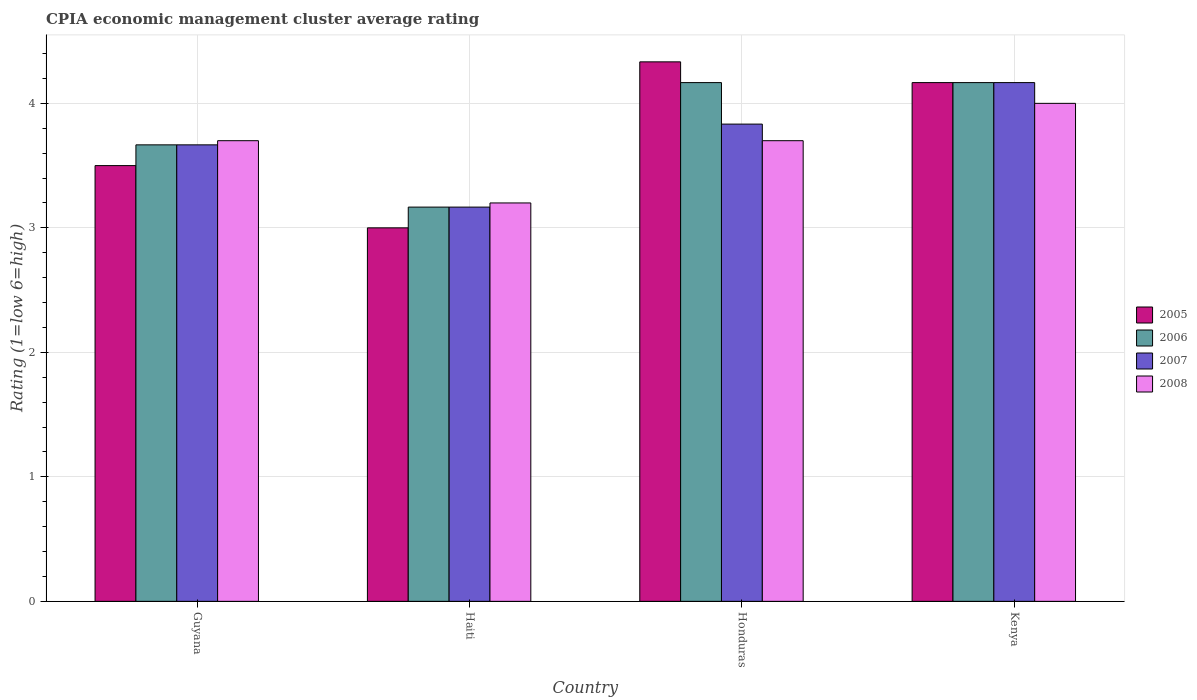Are the number of bars on each tick of the X-axis equal?
Ensure brevity in your answer.  Yes. How many bars are there on the 4th tick from the right?
Your answer should be compact. 4. What is the label of the 2nd group of bars from the left?
Offer a terse response. Haiti. What is the CPIA rating in 2006 in Kenya?
Ensure brevity in your answer.  4.17. Across all countries, what is the maximum CPIA rating in 2006?
Keep it short and to the point. 4.17. Across all countries, what is the minimum CPIA rating in 2005?
Offer a very short reply. 3. In which country was the CPIA rating in 2008 maximum?
Your answer should be compact. Kenya. In which country was the CPIA rating in 2006 minimum?
Give a very brief answer. Haiti. What is the total CPIA rating in 2005 in the graph?
Make the answer very short. 15. What is the difference between the CPIA rating in 2008 in Haiti and that in Honduras?
Offer a terse response. -0.5. What is the difference between the CPIA rating in 2008 in Honduras and the CPIA rating in 2007 in Haiti?
Your answer should be compact. 0.53. What is the average CPIA rating in 2006 per country?
Your answer should be compact. 3.79. What is the difference between the CPIA rating of/in 2007 and CPIA rating of/in 2006 in Kenya?
Offer a terse response. 0. In how many countries, is the CPIA rating in 2006 greater than 3.6?
Offer a terse response. 3. What is the ratio of the CPIA rating in 2006 in Honduras to that in Kenya?
Your answer should be compact. 1. Is the difference between the CPIA rating in 2007 in Guyana and Kenya greater than the difference between the CPIA rating in 2006 in Guyana and Kenya?
Ensure brevity in your answer.  No. What is the difference between the highest and the second highest CPIA rating in 2007?
Make the answer very short. -0.17. What is the difference between the highest and the lowest CPIA rating in 2007?
Offer a very short reply. 1. In how many countries, is the CPIA rating in 2007 greater than the average CPIA rating in 2007 taken over all countries?
Provide a succinct answer. 2. What does the 3rd bar from the left in Guyana represents?
Your response must be concise. 2007. What does the 2nd bar from the right in Honduras represents?
Your answer should be compact. 2007. How many bars are there?
Offer a very short reply. 16. Are all the bars in the graph horizontal?
Make the answer very short. No. How many countries are there in the graph?
Make the answer very short. 4. What is the difference between two consecutive major ticks on the Y-axis?
Your answer should be very brief. 1. Are the values on the major ticks of Y-axis written in scientific E-notation?
Provide a short and direct response. No. Does the graph contain any zero values?
Provide a short and direct response. No. How many legend labels are there?
Your answer should be compact. 4. How are the legend labels stacked?
Give a very brief answer. Vertical. What is the title of the graph?
Make the answer very short. CPIA economic management cluster average rating. Does "1974" appear as one of the legend labels in the graph?
Ensure brevity in your answer.  No. What is the label or title of the X-axis?
Your response must be concise. Country. What is the Rating (1=low 6=high) of 2005 in Guyana?
Your response must be concise. 3.5. What is the Rating (1=low 6=high) of 2006 in Guyana?
Your answer should be compact. 3.67. What is the Rating (1=low 6=high) of 2007 in Guyana?
Offer a very short reply. 3.67. What is the Rating (1=low 6=high) of 2008 in Guyana?
Your answer should be compact. 3.7. What is the Rating (1=low 6=high) in 2006 in Haiti?
Keep it short and to the point. 3.17. What is the Rating (1=low 6=high) of 2007 in Haiti?
Offer a terse response. 3.17. What is the Rating (1=low 6=high) in 2005 in Honduras?
Your answer should be very brief. 4.33. What is the Rating (1=low 6=high) of 2006 in Honduras?
Your answer should be compact. 4.17. What is the Rating (1=low 6=high) of 2007 in Honduras?
Give a very brief answer. 3.83. What is the Rating (1=low 6=high) in 2005 in Kenya?
Your answer should be very brief. 4.17. What is the Rating (1=low 6=high) in 2006 in Kenya?
Keep it short and to the point. 4.17. What is the Rating (1=low 6=high) of 2007 in Kenya?
Make the answer very short. 4.17. What is the Rating (1=low 6=high) of 2008 in Kenya?
Offer a very short reply. 4. Across all countries, what is the maximum Rating (1=low 6=high) of 2005?
Provide a succinct answer. 4.33. Across all countries, what is the maximum Rating (1=low 6=high) in 2006?
Offer a terse response. 4.17. Across all countries, what is the maximum Rating (1=low 6=high) of 2007?
Your answer should be compact. 4.17. Across all countries, what is the minimum Rating (1=low 6=high) in 2005?
Provide a succinct answer. 3. Across all countries, what is the minimum Rating (1=low 6=high) in 2006?
Make the answer very short. 3.17. Across all countries, what is the minimum Rating (1=low 6=high) in 2007?
Ensure brevity in your answer.  3.17. What is the total Rating (1=low 6=high) of 2005 in the graph?
Provide a succinct answer. 15. What is the total Rating (1=low 6=high) in 2006 in the graph?
Your response must be concise. 15.17. What is the total Rating (1=low 6=high) in 2007 in the graph?
Your answer should be very brief. 14.83. What is the difference between the Rating (1=low 6=high) of 2005 in Guyana and that in Haiti?
Provide a short and direct response. 0.5. What is the difference between the Rating (1=low 6=high) of 2007 in Guyana and that in Haiti?
Make the answer very short. 0.5. What is the difference between the Rating (1=low 6=high) of 2008 in Guyana and that in Haiti?
Provide a succinct answer. 0.5. What is the difference between the Rating (1=low 6=high) in 2006 in Guyana and that in Honduras?
Make the answer very short. -0.5. What is the difference between the Rating (1=low 6=high) in 2007 in Guyana and that in Honduras?
Your response must be concise. -0.17. What is the difference between the Rating (1=low 6=high) of 2008 in Guyana and that in Honduras?
Make the answer very short. 0. What is the difference between the Rating (1=low 6=high) of 2005 in Haiti and that in Honduras?
Provide a succinct answer. -1.33. What is the difference between the Rating (1=low 6=high) of 2007 in Haiti and that in Honduras?
Give a very brief answer. -0.67. What is the difference between the Rating (1=low 6=high) in 2005 in Haiti and that in Kenya?
Offer a terse response. -1.17. What is the difference between the Rating (1=low 6=high) of 2006 in Haiti and that in Kenya?
Offer a very short reply. -1. What is the difference between the Rating (1=low 6=high) of 2007 in Haiti and that in Kenya?
Your answer should be very brief. -1. What is the difference between the Rating (1=low 6=high) in 2008 in Haiti and that in Kenya?
Ensure brevity in your answer.  -0.8. What is the difference between the Rating (1=low 6=high) of 2005 in Honduras and that in Kenya?
Your answer should be very brief. 0.17. What is the difference between the Rating (1=low 6=high) of 2008 in Honduras and that in Kenya?
Provide a short and direct response. -0.3. What is the difference between the Rating (1=low 6=high) in 2006 in Guyana and the Rating (1=low 6=high) in 2007 in Haiti?
Ensure brevity in your answer.  0.5. What is the difference between the Rating (1=low 6=high) in 2006 in Guyana and the Rating (1=low 6=high) in 2008 in Haiti?
Offer a very short reply. 0.47. What is the difference between the Rating (1=low 6=high) of 2007 in Guyana and the Rating (1=low 6=high) of 2008 in Haiti?
Keep it short and to the point. 0.47. What is the difference between the Rating (1=low 6=high) in 2005 in Guyana and the Rating (1=low 6=high) in 2006 in Honduras?
Your answer should be compact. -0.67. What is the difference between the Rating (1=low 6=high) in 2006 in Guyana and the Rating (1=low 6=high) in 2007 in Honduras?
Offer a very short reply. -0.17. What is the difference between the Rating (1=low 6=high) in 2006 in Guyana and the Rating (1=low 6=high) in 2008 in Honduras?
Offer a very short reply. -0.03. What is the difference between the Rating (1=low 6=high) of 2007 in Guyana and the Rating (1=low 6=high) of 2008 in Honduras?
Offer a terse response. -0.03. What is the difference between the Rating (1=low 6=high) in 2005 in Guyana and the Rating (1=low 6=high) in 2006 in Kenya?
Provide a succinct answer. -0.67. What is the difference between the Rating (1=low 6=high) in 2007 in Guyana and the Rating (1=low 6=high) in 2008 in Kenya?
Your response must be concise. -0.33. What is the difference between the Rating (1=low 6=high) in 2005 in Haiti and the Rating (1=low 6=high) in 2006 in Honduras?
Give a very brief answer. -1.17. What is the difference between the Rating (1=low 6=high) of 2006 in Haiti and the Rating (1=low 6=high) of 2007 in Honduras?
Your answer should be compact. -0.67. What is the difference between the Rating (1=low 6=high) in 2006 in Haiti and the Rating (1=low 6=high) in 2008 in Honduras?
Ensure brevity in your answer.  -0.53. What is the difference between the Rating (1=low 6=high) of 2007 in Haiti and the Rating (1=low 6=high) of 2008 in Honduras?
Your answer should be compact. -0.53. What is the difference between the Rating (1=low 6=high) of 2005 in Haiti and the Rating (1=low 6=high) of 2006 in Kenya?
Provide a short and direct response. -1.17. What is the difference between the Rating (1=low 6=high) of 2005 in Haiti and the Rating (1=low 6=high) of 2007 in Kenya?
Offer a terse response. -1.17. What is the difference between the Rating (1=low 6=high) in 2005 in Haiti and the Rating (1=low 6=high) in 2008 in Kenya?
Give a very brief answer. -1. What is the difference between the Rating (1=low 6=high) in 2006 in Haiti and the Rating (1=low 6=high) in 2007 in Kenya?
Your answer should be compact. -1. What is the difference between the Rating (1=low 6=high) of 2006 in Haiti and the Rating (1=low 6=high) of 2008 in Kenya?
Provide a succinct answer. -0.83. What is the difference between the Rating (1=low 6=high) in 2007 in Haiti and the Rating (1=low 6=high) in 2008 in Kenya?
Offer a very short reply. -0.83. What is the difference between the Rating (1=low 6=high) of 2005 in Honduras and the Rating (1=low 6=high) of 2007 in Kenya?
Your answer should be compact. 0.17. What is the difference between the Rating (1=low 6=high) of 2005 in Honduras and the Rating (1=low 6=high) of 2008 in Kenya?
Make the answer very short. 0.33. What is the difference between the Rating (1=low 6=high) of 2006 in Honduras and the Rating (1=low 6=high) of 2008 in Kenya?
Ensure brevity in your answer.  0.17. What is the average Rating (1=low 6=high) in 2005 per country?
Keep it short and to the point. 3.75. What is the average Rating (1=low 6=high) of 2006 per country?
Ensure brevity in your answer.  3.79. What is the average Rating (1=low 6=high) of 2007 per country?
Make the answer very short. 3.71. What is the average Rating (1=low 6=high) of 2008 per country?
Make the answer very short. 3.65. What is the difference between the Rating (1=low 6=high) of 2006 and Rating (1=low 6=high) of 2008 in Guyana?
Keep it short and to the point. -0.03. What is the difference between the Rating (1=low 6=high) of 2007 and Rating (1=low 6=high) of 2008 in Guyana?
Your response must be concise. -0.03. What is the difference between the Rating (1=low 6=high) in 2005 and Rating (1=low 6=high) in 2006 in Haiti?
Offer a very short reply. -0.17. What is the difference between the Rating (1=low 6=high) in 2006 and Rating (1=low 6=high) in 2008 in Haiti?
Make the answer very short. -0.03. What is the difference between the Rating (1=low 6=high) of 2007 and Rating (1=low 6=high) of 2008 in Haiti?
Your answer should be very brief. -0.03. What is the difference between the Rating (1=low 6=high) in 2005 and Rating (1=low 6=high) in 2006 in Honduras?
Your answer should be very brief. 0.17. What is the difference between the Rating (1=low 6=high) of 2005 and Rating (1=low 6=high) of 2007 in Honduras?
Offer a very short reply. 0.5. What is the difference between the Rating (1=low 6=high) in 2005 and Rating (1=low 6=high) in 2008 in Honduras?
Keep it short and to the point. 0.63. What is the difference between the Rating (1=low 6=high) of 2006 and Rating (1=low 6=high) of 2007 in Honduras?
Your answer should be compact. 0.33. What is the difference between the Rating (1=low 6=high) of 2006 and Rating (1=low 6=high) of 2008 in Honduras?
Make the answer very short. 0.47. What is the difference between the Rating (1=low 6=high) of 2007 and Rating (1=low 6=high) of 2008 in Honduras?
Your answer should be compact. 0.13. What is the difference between the Rating (1=low 6=high) of 2005 and Rating (1=low 6=high) of 2007 in Kenya?
Offer a terse response. 0. What is the difference between the Rating (1=low 6=high) of 2007 and Rating (1=low 6=high) of 2008 in Kenya?
Provide a short and direct response. 0.17. What is the ratio of the Rating (1=low 6=high) in 2006 in Guyana to that in Haiti?
Your response must be concise. 1.16. What is the ratio of the Rating (1=low 6=high) in 2007 in Guyana to that in Haiti?
Provide a succinct answer. 1.16. What is the ratio of the Rating (1=low 6=high) in 2008 in Guyana to that in Haiti?
Make the answer very short. 1.16. What is the ratio of the Rating (1=low 6=high) of 2005 in Guyana to that in Honduras?
Make the answer very short. 0.81. What is the ratio of the Rating (1=low 6=high) of 2006 in Guyana to that in Honduras?
Your answer should be very brief. 0.88. What is the ratio of the Rating (1=low 6=high) of 2007 in Guyana to that in Honduras?
Keep it short and to the point. 0.96. What is the ratio of the Rating (1=low 6=high) in 2008 in Guyana to that in Honduras?
Provide a succinct answer. 1. What is the ratio of the Rating (1=low 6=high) of 2005 in Guyana to that in Kenya?
Keep it short and to the point. 0.84. What is the ratio of the Rating (1=low 6=high) in 2007 in Guyana to that in Kenya?
Provide a succinct answer. 0.88. What is the ratio of the Rating (1=low 6=high) of 2008 in Guyana to that in Kenya?
Your answer should be very brief. 0.93. What is the ratio of the Rating (1=low 6=high) in 2005 in Haiti to that in Honduras?
Offer a very short reply. 0.69. What is the ratio of the Rating (1=low 6=high) of 2006 in Haiti to that in Honduras?
Your answer should be very brief. 0.76. What is the ratio of the Rating (1=low 6=high) in 2007 in Haiti to that in Honduras?
Make the answer very short. 0.83. What is the ratio of the Rating (1=low 6=high) in 2008 in Haiti to that in Honduras?
Your response must be concise. 0.86. What is the ratio of the Rating (1=low 6=high) in 2005 in Haiti to that in Kenya?
Your answer should be very brief. 0.72. What is the ratio of the Rating (1=low 6=high) in 2006 in Haiti to that in Kenya?
Provide a succinct answer. 0.76. What is the ratio of the Rating (1=low 6=high) of 2007 in Haiti to that in Kenya?
Give a very brief answer. 0.76. What is the ratio of the Rating (1=low 6=high) in 2006 in Honduras to that in Kenya?
Make the answer very short. 1. What is the ratio of the Rating (1=low 6=high) of 2007 in Honduras to that in Kenya?
Your response must be concise. 0.92. What is the ratio of the Rating (1=low 6=high) in 2008 in Honduras to that in Kenya?
Offer a terse response. 0.93. What is the difference between the highest and the second highest Rating (1=low 6=high) in 2005?
Offer a terse response. 0.17. What is the difference between the highest and the second highest Rating (1=low 6=high) of 2006?
Make the answer very short. 0. What is the difference between the highest and the second highest Rating (1=low 6=high) in 2008?
Your answer should be very brief. 0.3. What is the difference between the highest and the lowest Rating (1=low 6=high) of 2005?
Offer a very short reply. 1.33. What is the difference between the highest and the lowest Rating (1=low 6=high) in 2007?
Offer a very short reply. 1. What is the difference between the highest and the lowest Rating (1=low 6=high) in 2008?
Ensure brevity in your answer.  0.8. 